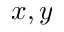Convert formula to latex. <formula><loc_0><loc_0><loc_500><loc_500>x , y</formula> 